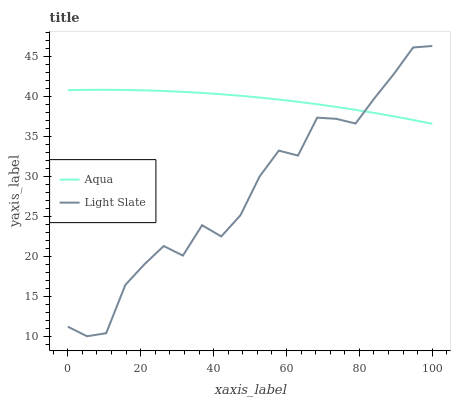Does Light Slate have the minimum area under the curve?
Answer yes or no. Yes. Does Aqua have the maximum area under the curve?
Answer yes or no. Yes. Does Aqua have the minimum area under the curve?
Answer yes or no. No. Is Aqua the smoothest?
Answer yes or no. Yes. Is Light Slate the roughest?
Answer yes or no. Yes. Is Aqua the roughest?
Answer yes or no. No. Does Light Slate have the lowest value?
Answer yes or no. Yes. Does Aqua have the lowest value?
Answer yes or no. No. Does Light Slate have the highest value?
Answer yes or no. Yes. Does Aqua have the highest value?
Answer yes or no. No. Does Aqua intersect Light Slate?
Answer yes or no. Yes. Is Aqua less than Light Slate?
Answer yes or no. No. Is Aqua greater than Light Slate?
Answer yes or no. No. 